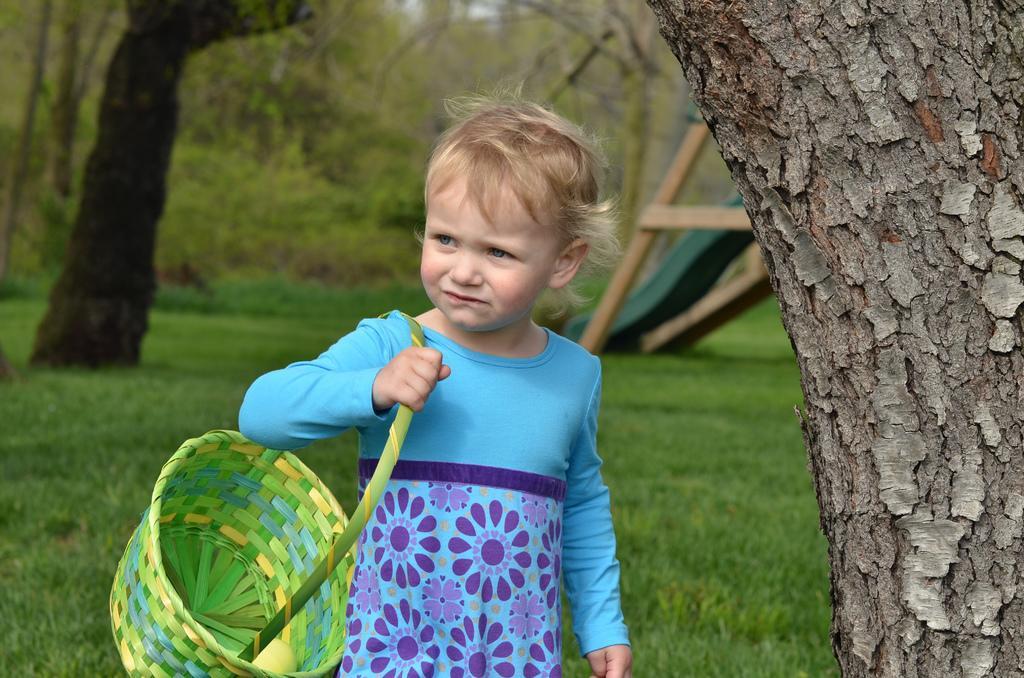How would you summarize this image in a sentence or two? In this image a kid wearing blue color top, holding basket on shoulder and walking on a green land, beside her there is a tree, in the background there are trees. 